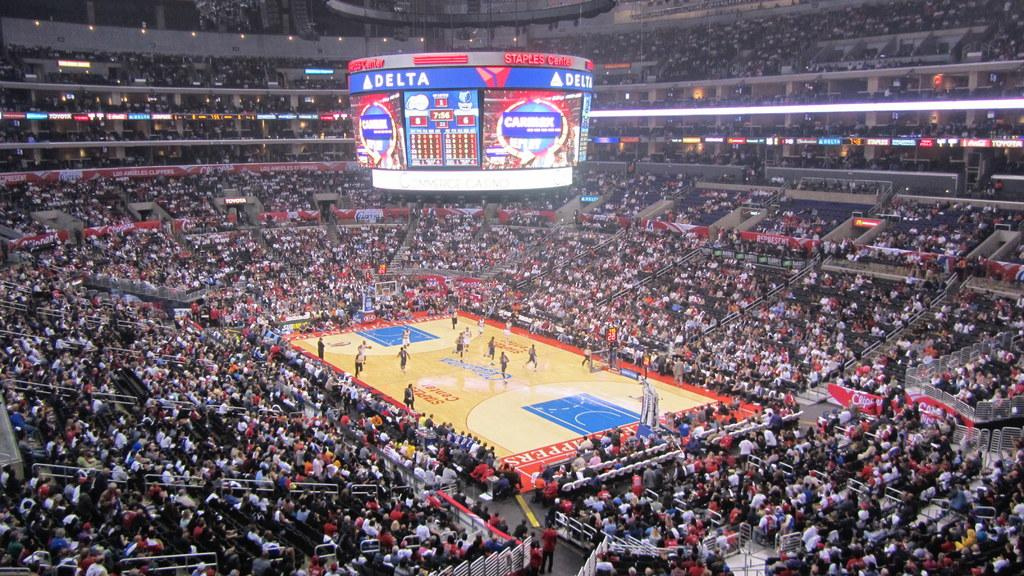<image>
Render a clear and concise summary of the photo. Delta's name is over the electronic board in the stadium ceiling. 